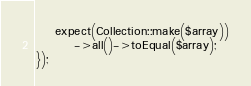Convert code to text. <code><loc_0><loc_0><loc_500><loc_500><_PHP_>    expect(Collection::make($array))
        ->all()->toEqual($array);
});
</code> 